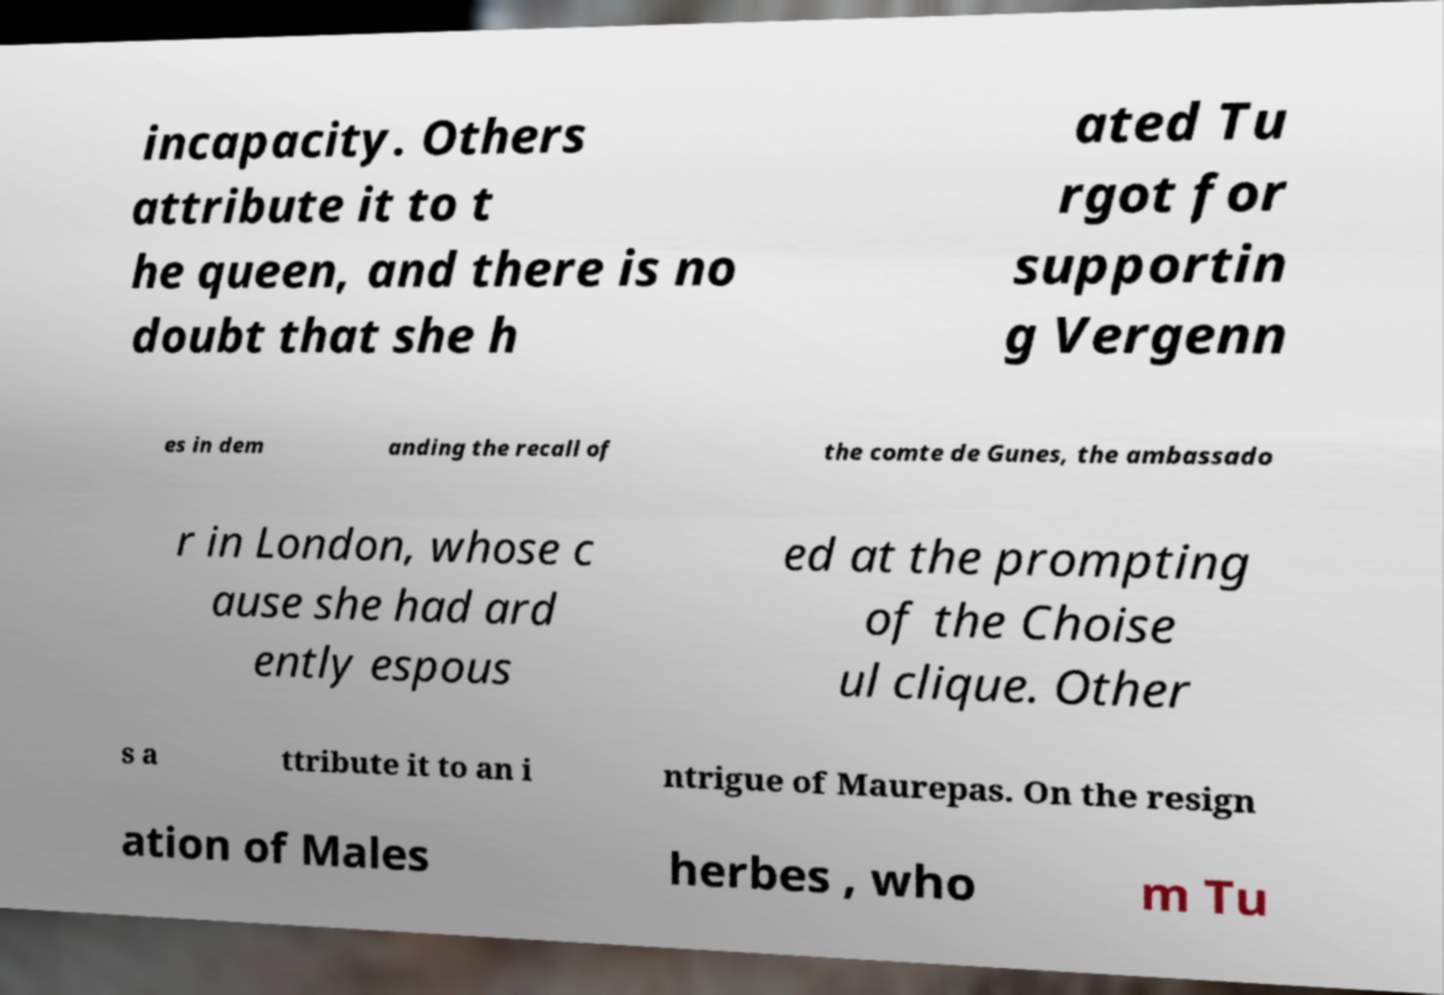Could you assist in decoding the text presented in this image and type it out clearly? incapacity. Others attribute it to t he queen, and there is no doubt that she h ated Tu rgot for supportin g Vergenn es in dem anding the recall of the comte de Gunes, the ambassado r in London, whose c ause she had ard ently espous ed at the prompting of the Choise ul clique. Other s a ttribute it to an i ntrigue of Maurepas. On the resign ation of Males herbes , who m Tu 